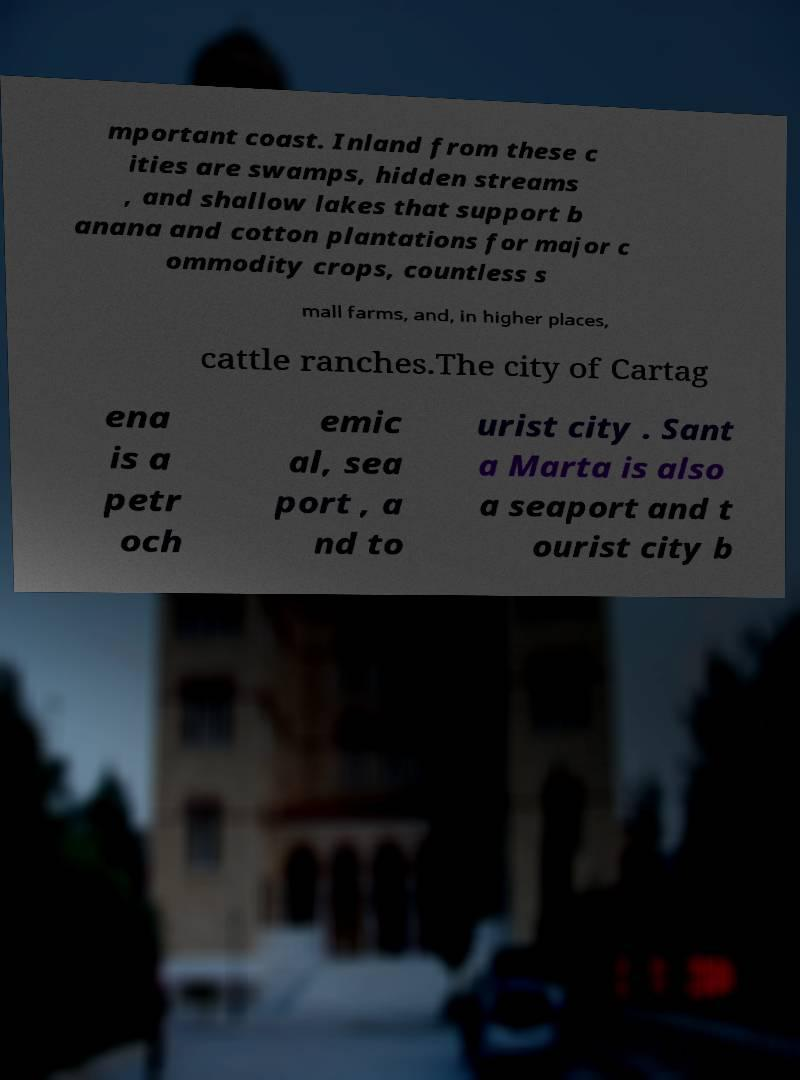Please identify and transcribe the text found in this image. mportant coast. Inland from these c ities are swamps, hidden streams , and shallow lakes that support b anana and cotton plantations for major c ommodity crops, countless s mall farms, and, in higher places, cattle ranches.The city of Cartag ena is a petr och emic al, sea port , a nd to urist city . Sant a Marta is also a seaport and t ourist city b 